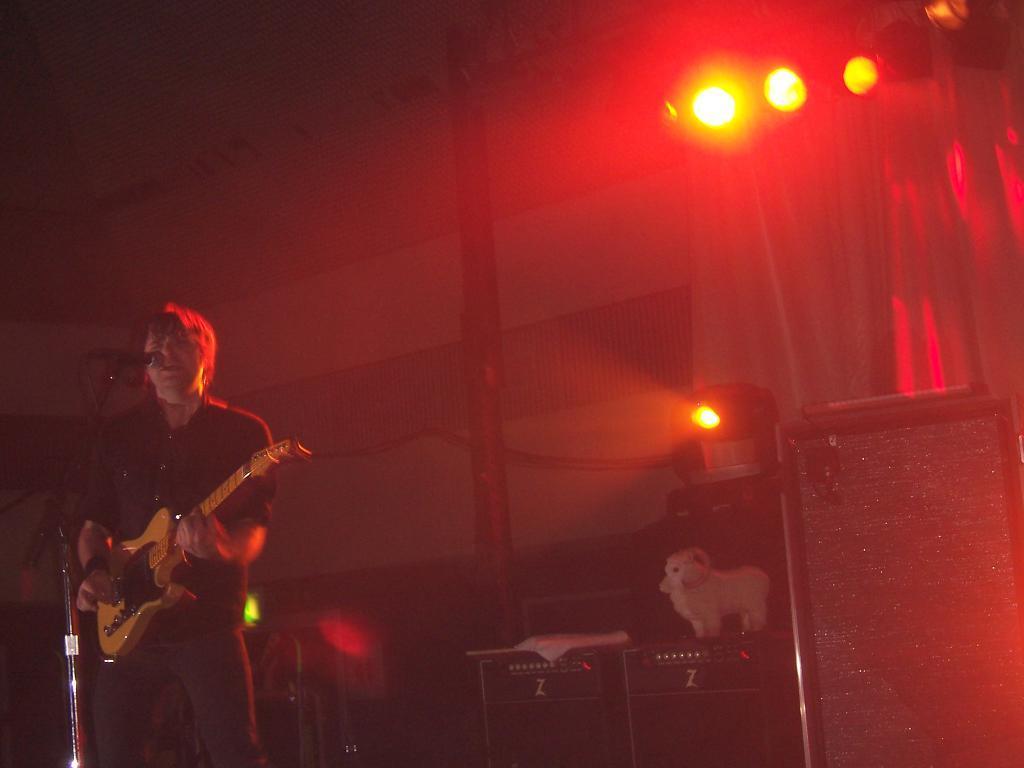Can you describe this image briefly? This picture is taken over a stage. on the left there is a person standing playing guitar, he is singing into a microphone. In the center of the picture there are speakers, on speakers there is a toy. On the top right there are focus lights and curtains. In the center of the background there is a pole. On the top left there is a wall. 